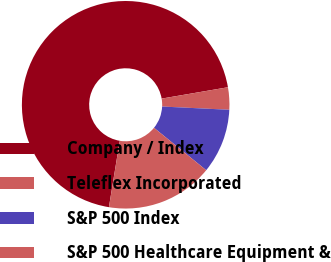Convert chart. <chart><loc_0><loc_0><loc_500><loc_500><pie_chart><fcel>Company / Index<fcel>Teleflex Incorporated<fcel>S&P 500 Index<fcel>S&P 500 Healthcare Equipment &<nl><fcel>69.72%<fcel>3.47%<fcel>10.09%<fcel>16.72%<nl></chart> 